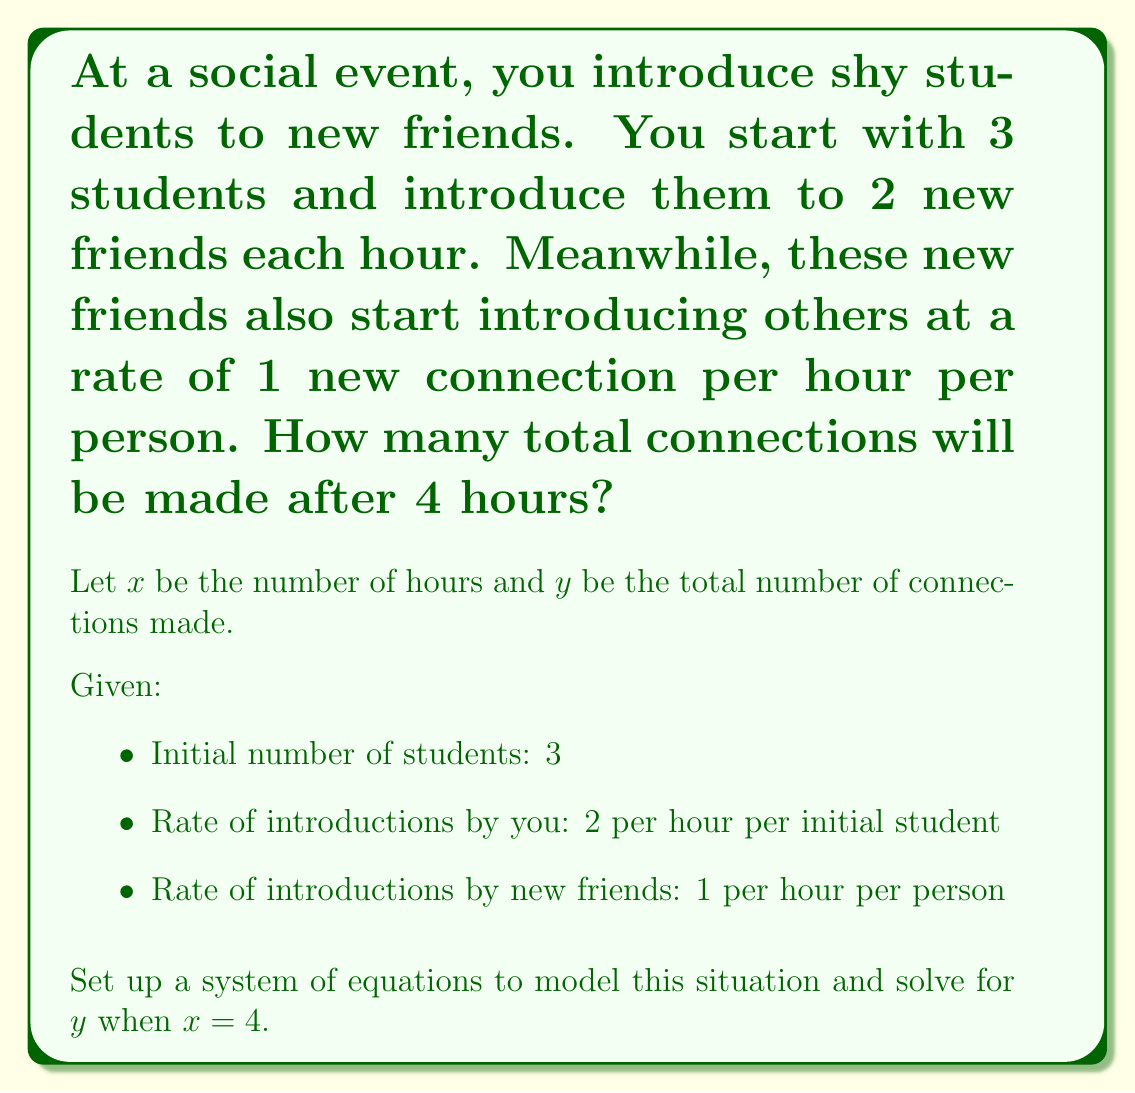Give your solution to this math problem. Let's approach this step-by-step:

1) First, let's set up an equation for the number of new friends introduced directly by you:
   $y_1 = 3 \cdot 2x = 6x$

2) Now, let's consider the introductions made by these new friends. At any given hour, the number of new friends is $6x$. Each of these friends makes 1 new connection per hour, but they don't start until the hour after they're introduced.

3) We can model this with the following series:
   $y_2 = 6(x-1) + 6(x-2) + 6(x-3) + ... + 6(1)$

4) This is an arithmetic series with $(x-1)$ terms. The sum of an arithmetic series is given by:
   $S_n = \frac{n(a_1 + a_n)}{2}$, where $n$ is the number of terms, $a_1$ is the first term, and $a_n$ is the last term.

5) In our case:
   $n = x-1$
   $a_1 = 6$
   $a_n = 6(x-1)$

6) Substituting into the formula:
   $y_2 = \frac{(x-1)(6 + 6(x-1))}{2} = \frac{(x-1)(6x)}{2} = 3x(x-1)$

7) The total number of connections is the sum of $y_1$ and $y_2$:
   $y = y_1 + y_2 = 6x + 3x(x-1) = 3x^2 + 3x$

8) Now we can substitute $x = 4$:
   $y = 3(4)^2 + 3(4) = 3(16) + 12 = 48 + 12 = 60$

Therefore, after 4 hours, 60 total connections will be made.
Answer: 60 connections 